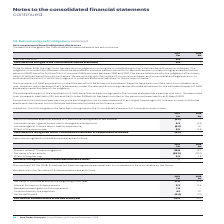According to Auto Trader's financial document, What has not been recognised as an asset in 2019? According to the financial document, surplus of £2.2m. The relevant text states: "The surplus of £2.2m (2018: £1.3m) has not been recognised as an asset as it is not deemed to be recoverable by the Grou..." Also, Why is the surplus not recognised as an asset? as it is not deemed to be recoverable by the Group. The document states: "(2018: £1.3m) has not been recognised as an asset as it is not deemed to be recoverable by the Group...." Also, What are the components considered under the Net asset recognised in the Consolidated balance sheet? The document contains multiple relevant values: Present value of funded obligations, Fair value of plan assets, Effect of surplus cap. From the document: "Effect of surplus cap 2.2 1.3 Fair value of plan assets (22.2) (21.0) Present value of funded obligations 20.0 19.7..." Additionally, In which year was the Effect of surplus cap larger? According to the financial document, 2019. The relevant text states: "2019 £m 2018 £m..." Also, can you calculate: What was the change in effect of surplus cap in 2019 from 2018? Based on the calculation: 2.2-1.3, the result is 0.9 (in millions). This is based on the information: "Effect of surplus cap 2.2 1.3 Effect of surplus cap 2.2 1.3..." The key data points involved are: 1.3, 2.2. Also, can you calculate: What was the percentage change in effect of surplus cap in 2019 from 2018? To answer this question, I need to perform calculations using the financial data. The calculation is: (2.2-1.3)/1.3, which equals 69.23 (percentage). This is based on the information: "Effect of surplus cap 2.2 1.3 Effect of surplus cap 2.2 1.3..." The key data points involved are: 1.3, 2.2. 